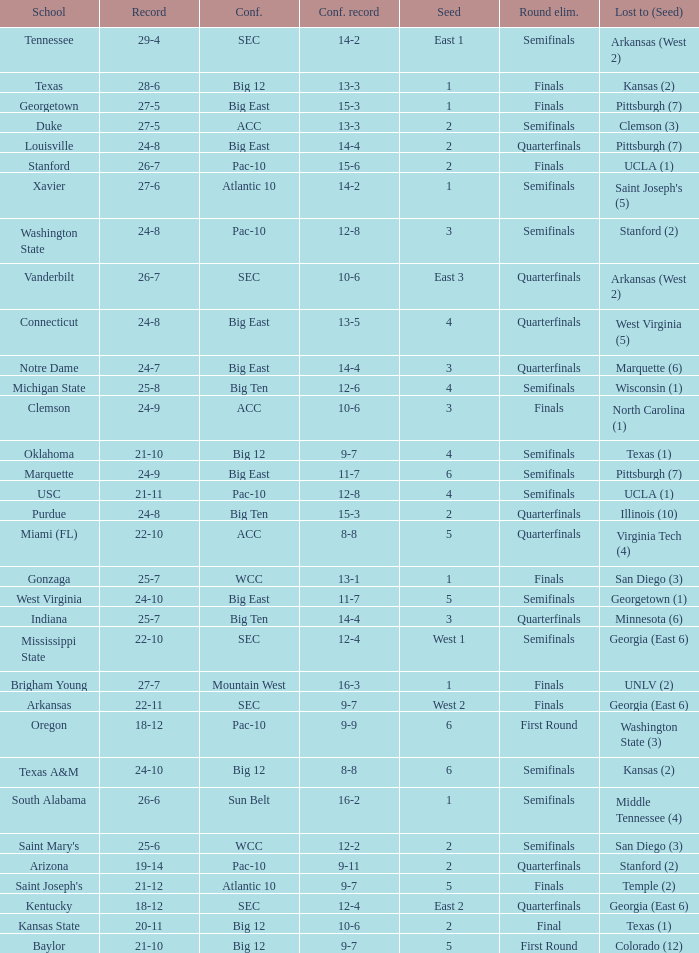Name the school where conference record is 12-6 Michigan State. 